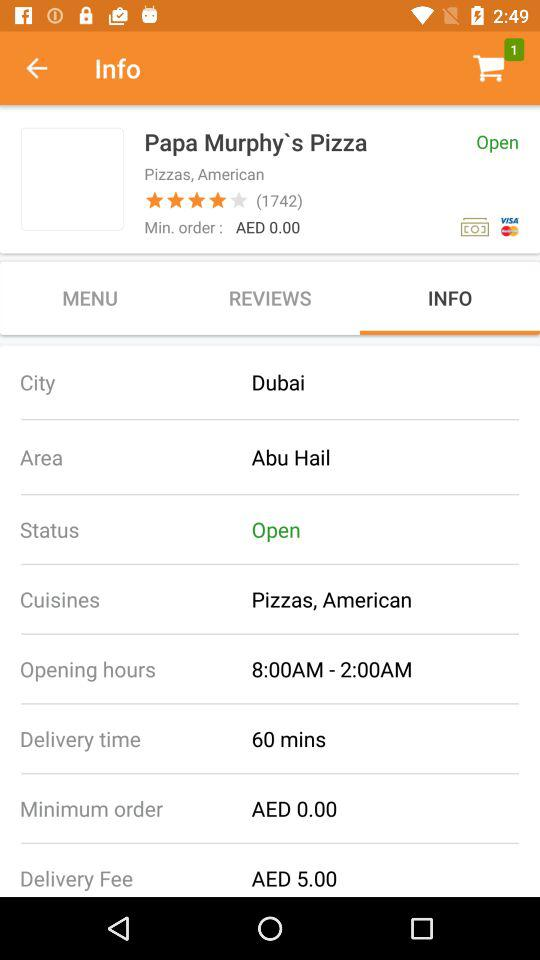What is the delivery fee for Papa Murphy's Pizza?
Answer the question using a single word or phrase. AED 5.00 